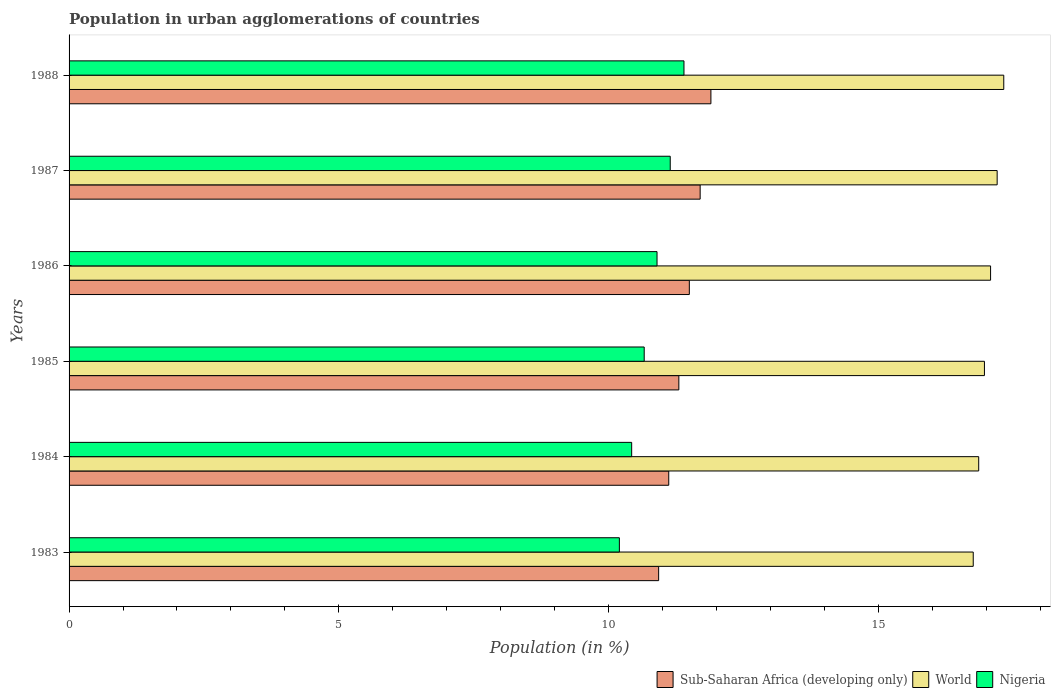How many different coloured bars are there?
Offer a very short reply. 3. How many groups of bars are there?
Ensure brevity in your answer.  6. Are the number of bars per tick equal to the number of legend labels?
Keep it short and to the point. Yes. How many bars are there on the 4th tick from the bottom?
Offer a terse response. 3. What is the label of the 6th group of bars from the top?
Keep it short and to the point. 1983. In how many cases, is the number of bars for a given year not equal to the number of legend labels?
Offer a very short reply. 0. What is the percentage of population in urban agglomerations in Nigeria in 1983?
Your answer should be compact. 10.2. Across all years, what is the maximum percentage of population in urban agglomerations in Sub-Saharan Africa (developing only)?
Your answer should be very brief. 11.9. Across all years, what is the minimum percentage of population in urban agglomerations in Sub-Saharan Africa (developing only)?
Offer a terse response. 10.93. In which year was the percentage of population in urban agglomerations in Nigeria minimum?
Your response must be concise. 1983. What is the total percentage of population in urban agglomerations in World in the graph?
Offer a very short reply. 102.2. What is the difference between the percentage of population in urban agglomerations in World in 1985 and that in 1987?
Your response must be concise. -0.24. What is the difference between the percentage of population in urban agglomerations in Sub-Saharan Africa (developing only) in 1988 and the percentage of population in urban agglomerations in World in 1984?
Offer a terse response. -4.96. What is the average percentage of population in urban agglomerations in World per year?
Provide a succinct answer. 17.03. In the year 1984, what is the difference between the percentage of population in urban agglomerations in World and percentage of population in urban agglomerations in Nigeria?
Provide a succinct answer. 6.43. What is the ratio of the percentage of population in urban agglomerations in Nigeria in 1985 to that in 1988?
Provide a succinct answer. 0.94. Is the difference between the percentage of population in urban agglomerations in World in 1985 and 1987 greater than the difference between the percentage of population in urban agglomerations in Nigeria in 1985 and 1987?
Your response must be concise. Yes. What is the difference between the highest and the second highest percentage of population in urban agglomerations in Sub-Saharan Africa (developing only)?
Give a very brief answer. 0.2. What is the difference between the highest and the lowest percentage of population in urban agglomerations in World?
Ensure brevity in your answer.  0.57. Is the sum of the percentage of population in urban agglomerations in Sub-Saharan Africa (developing only) in 1983 and 1984 greater than the maximum percentage of population in urban agglomerations in Nigeria across all years?
Provide a short and direct response. Yes. What does the 3rd bar from the top in 1988 represents?
Offer a very short reply. Sub-Saharan Africa (developing only). What does the 2nd bar from the bottom in 1987 represents?
Provide a short and direct response. World. Is it the case that in every year, the sum of the percentage of population in urban agglomerations in Sub-Saharan Africa (developing only) and percentage of population in urban agglomerations in Nigeria is greater than the percentage of population in urban agglomerations in World?
Ensure brevity in your answer.  Yes. Are all the bars in the graph horizontal?
Offer a terse response. Yes. How many years are there in the graph?
Provide a succinct answer. 6. Are the values on the major ticks of X-axis written in scientific E-notation?
Keep it short and to the point. No. Does the graph contain any zero values?
Give a very brief answer. No. Where does the legend appear in the graph?
Keep it short and to the point. Bottom right. How many legend labels are there?
Provide a succinct answer. 3. How are the legend labels stacked?
Offer a terse response. Horizontal. What is the title of the graph?
Give a very brief answer. Population in urban agglomerations of countries. What is the label or title of the Y-axis?
Your response must be concise. Years. What is the Population (in %) in Sub-Saharan Africa (developing only) in 1983?
Make the answer very short. 10.93. What is the Population (in %) in World in 1983?
Provide a short and direct response. 16.76. What is the Population (in %) in Nigeria in 1983?
Offer a terse response. 10.2. What is the Population (in %) in Sub-Saharan Africa (developing only) in 1984?
Keep it short and to the point. 11.12. What is the Population (in %) in World in 1984?
Offer a terse response. 16.86. What is the Population (in %) of Nigeria in 1984?
Your response must be concise. 10.43. What is the Population (in %) in Sub-Saharan Africa (developing only) in 1985?
Offer a very short reply. 11.3. What is the Population (in %) in World in 1985?
Keep it short and to the point. 16.97. What is the Population (in %) of Nigeria in 1985?
Your response must be concise. 10.66. What is the Population (in %) in Sub-Saharan Africa (developing only) in 1986?
Your answer should be very brief. 11.5. What is the Population (in %) of World in 1986?
Your answer should be compact. 17.08. What is the Population (in %) of Nigeria in 1986?
Offer a very short reply. 10.9. What is the Population (in %) of Sub-Saharan Africa (developing only) in 1987?
Make the answer very short. 11.7. What is the Population (in %) of World in 1987?
Give a very brief answer. 17.2. What is the Population (in %) of Nigeria in 1987?
Keep it short and to the point. 11.14. What is the Population (in %) in Sub-Saharan Africa (developing only) in 1988?
Keep it short and to the point. 11.9. What is the Population (in %) of World in 1988?
Provide a succinct answer. 17.33. What is the Population (in %) in Nigeria in 1988?
Provide a succinct answer. 11.4. Across all years, what is the maximum Population (in %) in Sub-Saharan Africa (developing only)?
Keep it short and to the point. 11.9. Across all years, what is the maximum Population (in %) of World?
Your response must be concise. 17.33. Across all years, what is the maximum Population (in %) in Nigeria?
Provide a short and direct response. 11.4. Across all years, what is the minimum Population (in %) in Sub-Saharan Africa (developing only)?
Keep it short and to the point. 10.93. Across all years, what is the minimum Population (in %) of World?
Your answer should be compact. 16.76. Across all years, what is the minimum Population (in %) in Nigeria?
Provide a succinct answer. 10.2. What is the total Population (in %) in Sub-Saharan Africa (developing only) in the graph?
Provide a succinct answer. 68.44. What is the total Population (in %) in World in the graph?
Offer a very short reply. 102.2. What is the total Population (in %) in Nigeria in the graph?
Provide a succinct answer. 64.73. What is the difference between the Population (in %) in Sub-Saharan Africa (developing only) in 1983 and that in 1984?
Your answer should be compact. -0.19. What is the difference between the Population (in %) in World in 1983 and that in 1984?
Make the answer very short. -0.1. What is the difference between the Population (in %) in Nigeria in 1983 and that in 1984?
Keep it short and to the point. -0.23. What is the difference between the Population (in %) of Sub-Saharan Africa (developing only) in 1983 and that in 1985?
Give a very brief answer. -0.37. What is the difference between the Population (in %) of World in 1983 and that in 1985?
Offer a very short reply. -0.21. What is the difference between the Population (in %) in Nigeria in 1983 and that in 1985?
Your answer should be very brief. -0.46. What is the difference between the Population (in %) of Sub-Saharan Africa (developing only) in 1983 and that in 1986?
Your answer should be compact. -0.57. What is the difference between the Population (in %) in World in 1983 and that in 1986?
Keep it short and to the point. -0.32. What is the difference between the Population (in %) in Nigeria in 1983 and that in 1986?
Make the answer very short. -0.7. What is the difference between the Population (in %) of Sub-Saharan Africa (developing only) in 1983 and that in 1987?
Your answer should be compact. -0.77. What is the difference between the Population (in %) of World in 1983 and that in 1987?
Provide a short and direct response. -0.44. What is the difference between the Population (in %) in Nigeria in 1983 and that in 1987?
Offer a terse response. -0.94. What is the difference between the Population (in %) in Sub-Saharan Africa (developing only) in 1983 and that in 1988?
Make the answer very short. -0.97. What is the difference between the Population (in %) in World in 1983 and that in 1988?
Your answer should be compact. -0.57. What is the difference between the Population (in %) of Nigeria in 1983 and that in 1988?
Ensure brevity in your answer.  -1.2. What is the difference between the Population (in %) of Sub-Saharan Africa (developing only) in 1984 and that in 1985?
Make the answer very short. -0.19. What is the difference between the Population (in %) in World in 1984 and that in 1985?
Give a very brief answer. -0.11. What is the difference between the Population (in %) of Nigeria in 1984 and that in 1985?
Keep it short and to the point. -0.23. What is the difference between the Population (in %) in Sub-Saharan Africa (developing only) in 1984 and that in 1986?
Provide a succinct answer. -0.38. What is the difference between the Population (in %) of World in 1984 and that in 1986?
Your response must be concise. -0.22. What is the difference between the Population (in %) of Nigeria in 1984 and that in 1986?
Your answer should be very brief. -0.47. What is the difference between the Population (in %) in Sub-Saharan Africa (developing only) in 1984 and that in 1987?
Provide a short and direct response. -0.58. What is the difference between the Population (in %) of World in 1984 and that in 1987?
Offer a very short reply. -0.34. What is the difference between the Population (in %) in Nigeria in 1984 and that in 1987?
Make the answer very short. -0.71. What is the difference between the Population (in %) of Sub-Saharan Africa (developing only) in 1984 and that in 1988?
Offer a terse response. -0.78. What is the difference between the Population (in %) of World in 1984 and that in 1988?
Provide a short and direct response. -0.46. What is the difference between the Population (in %) in Nigeria in 1984 and that in 1988?
Your response must be concise. -0.97. What is the difference between the Population (in %) in Sub-Saharan Africa (developing only) in 1985 and that in 1986?
Your answer should be very brief. -0.19. What is the difference between the Population (in %) of World in 1985 and that in 1986?
Your response must be concise. -0.11. What is the difference between the Population (in %) in Nigeria in 1985 and that in 1986?
Your answer should be compact. -0.24. What is the difference between the Population (in %) in Sub-Saharan Africa (developing only) in 1985 and that in 1987?
Your response must be concise. -0.4. What is the difference between the Population (in %) in World in 1985 and that in 1987?
Keep it short and to the point. -0.24. What is the difference between the Population (in %) in Nigeria in 1985 and that in 1987?
Provide a short and direct response. -0.48. What is the difference between the Population (in %) in Sub-Saharan Africa (developing only) in 1985 and that in 1988?
Make the answer very short. -0.59. What is the difference between the Population (in %) of World in 1985 and that in 1988?
Give a very brief answer. -0.36. What is the difference between the Population (in %) in Nigeria in 1985 and that in 1988?
Offer a very short reply. -0.74. What is the difference between the Population (in %) of Sub-Saharan Africa (developing only) in 1986 and that in 1987?
Provide a succinct answer. -0.2. What is the difference between the Population (in %) in World in 1986 and that in 1987?
Make the answer very short. -0.12. What is the difference between the Population (in %) of Nigeria in 1986 and that in 1987?
Your answer should be very brief. -0.24. What is the difference between the Population (in %) of Sub-Saharan Africa (developing only) in 1986 and that in 1988?
Your response must be concise. -0.4. What is the difference between the Population (in %) in World in 1986 and that in 1988?
Ensure brevity in your answer.  -0.24. What is the difference between the Population (in %) of Nigeria in 1986 and that in 1988?
Your answer should be very brief. -0.5. What is the difference between the Population (in %) in Sub-Saharan Africa (developing only) in 1987 and that in 1988?
Provide a short and direct response. -0.2. What is the difference between the Population (in %) of World in 1987 and that in 1988?
Offer a terse response. -0.12. What is the difference between the Population (in %) in Nigeria in 1987 and that in 1988?
Provide a succinct answer. -0.25. What is the difference between the Population (in %) in Sub-Saharan Africa (developing only) in 1983 and the Population (in %) in World in 1984?
Your response must be concise. -5.93. What is the difference between the Population (in %) of Sub-Saharan Africa (developing only) in 1983 and the Population (in %) of Nigeria in 1984?
Your answer should be compact. 0.5. What is the difference between the Population (in %) of World in 1983 and the Population (in %) of Nigeria in 1984?
Provide a short and direct response. 6.33. What is the difference between the Population (in %) of Sub-Saharan Africa (developing only) in 1983 and the Population (in %) of World in 1985?
Provide a short and direct response. -6.04. What is the difference between the Population (in %) of Sub-Saharan Africa (developing only) in 1983 and the Population (in %) of Nigeria in 1985?
Provide a short and direct response. 0.27. What is the difference between the Population (in %) in World in 1983 and the Population (in %) in Nigeria in 1985?
Keep it short and to the point. 6.1. What is the difference between the Population (in %) in Sub-Saharan Africa (developing only) in 1983 and the Population (in %) in World in 1986?
Ensure brevity in your answer.  -6.15. What is the difference between the Population (in %) in Sub-Saharan Africa (developing only) in 1983 and the Population (in %) in Nigeria in 1986?
Your answer should be very brief. 0.03. What is the difference between the Population (in %) of World in 1983 and the Population (in %) of Nigeria in 1986?
Provide a short and direct response. 5.86. What is the difference between the Population (in %) in Sub-Saharan Africa (developing only) in 1983 and the Population (in %) in World in 1987?
Provide a short and direct response. -6.28. What is the difference between the Population (in %) of Sub-Saharan Africa (developing only) in 1983 and the Population (in %) of Nigeria in 1987?
Your answer should be very brief. -0.21. What is the difference between the Population (in %) in World in 1983 and the Population (in %) in Nigeria in 1987?
Your response must be concise. 5.62. What is the difference between the Population (in %) of Sub-Saharan Africa (developing only) in 1983 and the Population (in %) of World in 1988?
Provide a succinct answer. -6.4. What is the difference between the Population (in %) in Sub-Saharan Africa (developing only) in 1983 and the Population (in %) in Nigeria in 1988?
Your answer should be compact. -0.47. What is the difference between the Population (in %) in World in 1983 and the Population (in %) in Nigeria in 1988?
Keep it short and to the point. 5.36. What is the difference between the Population (in %) in Sub-Saharan Africa (developing only) in 1984 and the Population (in %) in World in 1985?
Your answer should be very brief. -5.85. What is the difference between the Population (in %) in Sub-Saharan Africa (developing only) in 1984 and the Population (in %) in Nigeria in 1985?
Provide a succinct answer. 0.45. What is the difference between the Population (in %) of World in 1984 and the Population (in %) of Nigeria in 1985?
Your answer should be compact. 6.2. What is the difference between the Population (in %) of Sub-Saharan Africa (developing only) in 1984 and the Population (in %) of World in 1986?
Give a very brief answer. -5.97. What is the difference between the Population (in %) in Sub-Saharan Africa (developing only) in 1984 and the Population (in %) in Nigeria in 1986?
Offer a very short reply. 0.22. What is the difference between the Population (in %) in World in 1984 and the Population (in %) in Nigeria in 1986?
Provide a short and direct response. 5.96. What is the difference between the Population (in %) of Sub-Saharan Africa (developing only) in 1984 and the Population (in %) of World in 1987?
Provide a short and direct response. -6.09. What is the difference between the Population (in %) of Sub-Saharan Africa (developing only) in 1984 and the Population (in %) of Nigeria in 1987?
Provide a succinct answer. -0.03. What is the difference between the Population (in %) of World in 1984 and the Population (in %) of Nigeria in 1987?
Give a very brief answer. 5.72. What is the difference between the Population (in %) in Sub-Saharan Africa (developing only) in 1984 and the Population (in %) in World in 1988?
Keep it short and to the point. -6.21. What is the difference between the Population (in %) of Sub-Saharan Africa (developing only) in 1984 and the Population (in %) of Nigeria in 1988?
Give a very brief answer. -0.28. What is the difference between the Population (in %) of World in 1984 and the Population (in %) of Nigeria in 1988?
Offer a very short reply. 5.46. What is the difference between the Population (in %) of Sub-Saharan Africa (developing only) in 1985 and the Population (in %) of World in 1986?
Ensure brevity in your answer.  -5.78. What is the difference between the Population (in %) in Sub-Saharan Africa (developing only) in 1985 and the Population (in %) in Nigeria in 1986?
Make the answer very short. 0.4. What is the difference between the Population (in %) in World in 1985 and the Population (in %) in Nigeria in 1986?
Your answer should be very brief. 6.07. What is the difference between the Population (in %) in Sub-Saharan Africa (developing only) in 1985 and the Population (in %) in World in 1987?
Make the answer very short. -5.9. What is the difference between the Population (in %) of Sub-Saharan Africa (developing only) in 1985 and the Population (in %) of Nigeria in 1987?
Offer a very short reply. 0.16. What is the difference between the Population (in %) of World in 1985 and the Population (in %) of Nigeria in 1987?
Keep it short and to the point. 5.82. What is the difference between the Population (in %) in Sub-Saharan Africa (developing only) in 1985 and the Population (in %) in World in 1988?
Your response must be concise. -6.02. What is the difference between the Population (in %) of Sub-Saharan Africa (developing only) in 1985 and the Population (in %) of Nigeria in 1988?
Your response must be concise. -0.09. What is the difference between the Population (in %) of World in 1985 and the Population (in %) of Nigeria in 1988?
Your answer should be very brief. 5.57. What is the difference between the Population (in %) in Sub-Saharan Africa (developing only) in 1986 and the Population (in %) in World in 1987?
Ensure brevity in your answer.  -5.71. What is the difference between the Population (in %) in Sub-Saharan Africa (developing only) in 1986 and the Population (in %) in Nigeria in 1987?
Ensure brevity in your answer.  0.35. What is the difference between the Population (in %) in World in 1986 and the Population (in %) in Nigeria in 1987?
Offer a very short reply. 5.94. What is the difference between the Population (in %) in Sub-Saharan Africa (developing only) in 1986 and the Population (in %) in World in 1988?
Your answer should be compact. -5.83. What is the difference between the Population (in %) in Sub-Saharan Africa (developing only) in 1986 and the Population (in %) in Nigeria in 1988?
Your answer should be very brief. 0.1. What is the difference between the Population (in %) of World in 1986 and the Population (in %) of Nigeria in 1988?
Make the answer very short. 5.68. What is the difference between the Population (in %) of Sub-Saharan Africa (developing only) in 1987 and the Population (in %) of World in 1988?
Ensure brevity in your answer.  -5.63. What is the difference between the Population (in %) in Sub-Saharan Africa (developing only) in 1987 and the Population (in %) in Nigeria in 1988?
Provide a short and direct response. 0.3. What is the difference between the Population (in %) in World in 1987 and the Population (in %) in Nigeria in 1988?
Provide a short and direct response. 5.81. What is the average Population (in %) of Sub-Saharan Africa (developing only) per year?
Your answer should be very brief. 11.41. What is the average Population (in %) in World per year?
Ensure brevity in your answer.  17.03. What is the average Population (in %) of Nigeria per year?
Offer a terse response. 10.79. In the year 1983, what is the difference between the Population (in %) in Sub-Saharan Africa (developing only) and Population (in %) in World?
Make the answer very short. -5.83. In the year 1983, what is the difference between the Population (in %) in Sub-Saharan Africa (developing only) and Population (in %) in Nigeria?
Ensure brevity in your answer.  0.73. In the year 1983, what is the difference between the Population (in %) in World and Population (in %) in Nigeria?
Provide a succinct answer. 6.56. In the year 1984, what is the difference between the Population (in %) of Sub-Saharan Africa (developing only) and Population (in %) of World?
Provide a succinct answer. -5.75. In the year 1984, what is the difference between the Population (in %) of Sub-Saharan Africa (developing only) and Population (in %) of Nigeria?
Keep it short and to the point. 0.69. In the year 1984, what is the difference between the Population (in %) of World and Population (in %) of Nigeria?
Your answer should be compact. 6.43. In the year 1985, what is the difference between the Population (in %) in Sub-Saharan Africa (developing only) and Population (in %) in World?
Your answer should be compact. -5.66. In the year 1985, what is the difference between the Population (in %) in Sub-Saharan Africa (developing only) and Population (in %) in Nigeria?
Offer a very short reply. 0.64. In the year 1985, what is the difference between the Population (in %) of World and Population (in %) of Nigeria?
Make the answer very short. 6.31. In the year 1986, what is the difference between the Population (in %) of Sub-Saharan Africa (developing only) and Population (in %) of World?
Provide a short and direct response. -5.58. In the year 1986, what is the difference between the Population (in %) of Sub-Saharan Africa (developing only) and Population (in %) of Nigeria?
Make the answer very short. 0.6. In the year 1986, what is the difference between the Population (in %) of World and Population (in %) of Nigeria?
Ensure brevity in your answer.  6.18. In the year 1987, what is the difference between the Population (in %) in Sub-Saharan Africa (developing only) and Population (in %) in World?
Give a very brief answer. -5.51. In the year 1987, what is the difference between the Population (in %) in Sub-Saharan Africa (developing only) and Population (in %) in Nigeria?
Give a very brief answer. 0.55. In the year 1987, what is the difference between the Population (in %) of World and Population (in %) of Nigeria?
Provide a short and direct response. 6.06. In the year 1988, what is the difference between the Population (in %) of Sub-Saharan Africa (developing only) and Population (in %) of World?
Give a very brief answer. -5.43. In the year 1988, what is the difference between the Population (in %) of Sub-Saharan Africa (developing only) and Population (in %) of Nigeria?
Your answer should be very brief. 0.5. In the year 1988, what is the difference between the Population (in %) of World and Population (in %) of Nigeria?
Your response must be concise. 5.93. What is the ratio of the Population (in %) of Sub-Saharan Africa (developing only) in 1983 to that in 1984?
Your answer should be compact. 0.98. What is the ratio of the Population (in %) of World in 1983 to that in 1984?
Provide a short and direct response. 0.99. What is the ratio of the Population (in %) in Nigeria in 1983 to that in 1984?
Your answer should be compact. 0.98. What is the ratio of the Population (in %) in Sub-Saharan Africa (developing only) in 1983 to that in 1985?
Give a very brief answer. 0.97. What is the ratio of the Population (in %) in Nigeria in 1983 to that in 1985?
Provide a short and direct response. 0.96. What is the ratio of the Population (in %) in Sub-Saharan Africa (developing only) in 1983 to that in 1986?
Offer a terse response. 0.95. What is the ratio of the Population (in %) in World in 1983 to that in 1986?
Your response must be concise. 0.98. What is the ratio of the Population (in %) of Nigeria in 1983 to that in 1986?
Offer a terse response. 0.94. What is the ratio of the Population (in %) in Sub-Saharan Africa (developing only) in 1983 to that in 1987?
Your answer should be compact. 0.93. What is the ratio of the Population (in %) in World in 1983 to that in 1987?
Offer a very short reply. 0.97. What is the ratio of the Population (in %) in Nigeria in 1983 to that in 1987?
Your answer should be very brief. 0.92. What is the ratio of the Population (in %) in Sub-Saharan Africa (developing only) in 1983 to that in 1988?
Ensure brevity in your answer.  0.92. What is the ratio of the Population (in %) in World in 1983 to that in 1988?
Provide a succinct answer. 0.97. What is the ratio of the Population (in %) in Nigeria in 1983 to that in 1988?
Offer a very short reply. 0.89. What is the ratio of the Population (in %) in Sub-Saharan Africa (developing only) in 1984 to that in 1985?
Offer a terse response. 0.98. What is the ratio of the Population (in %) of World in 1984 to that in 1985?
Ensure brevity in your answer.  0.99. What is the ratio of the Population (in %) of Nigeria in 1984 to that in 1985?
Your response must be concise. 0.98. What is the ratio of the Population (in %) in Sub-Saharan Africa (developing only) in 1984 to that in 1986?
Offer a terse response. 0.97. What is the ratio of the Population (in %) of World in 1984 to that in 1986?
Ensure brevity in your answer.  0.99. What is the ratio of the Population (in %) in Nigeria in 1984 to that in 1986?
Your answer should be very brief. 0.96. What is the ratio of the Population (in %) of Sub-Saharan Africa (developing only) in 1984 to that in 1987?
Ensure brevity in your answer.  0.95. What is the ratio of the Population (in %) of World in 1984 to that in 1987?
Keep it short and to the point. 0.98. What is the ratio of the Population (in %) in Nigeria in 1984 to that in 1987?
Ensure brevity in your answer.  0.94. What is the ratio of the Population (in %) of Sub-Saharan Africa (developing only) in 1984 to that in 1988?
Provide a short and direct response. 0.93. What is the ratio of the Population (in %) in World in 1984 to that in 1988?
Your answer should be very brief. 0.97. What is the ratio of the Population (in %) of Nigeria in 1984 to that in 1988?
Give a very brief answer. 0.92. What is the ratio of the Population (in %) of Sub-Saharan Africa (developing only) in 1985 to that in 1986?
Your answer should be compact. 0.98. What is the ratio of the Population (in %) of Nigeria in 1985 to that in 1986?
Keep it short and to the point. 0.98. What is the ratio of the Population (in %) in Sub-Saharan Africa (developing only) in 1985 to that in 1987?
Give a very brief answer. 0.97. What is the ratio of the Population (in %) of World in 1985 to that in 1987?
Your answer should be compact. 0.99. What is the ratio of the Population (in %) of Nigeria in 1985 to that in 1987?
Provide a succinct answer. 0.96. What is the ratio of the Population (in %) of Sub-Saharan Africa (developing only) in 1985 to that in 1988?
Offer a terse response. 0.95. What is the ratio of the Population (in %) of World in 1985 to that in 1988?
Offer a very short reply. 0.98. What is the ratio of the Population (in %) of Nigeria in 1985 to that in 1988?
Provide a succinct answer. 0.94. What is the ratio of the Population (in %) in Sub-Saharan Africa (developing only) in 1986 to that in 1987?
Your answer should be compact. 0.98. What is the ratio of the Population (in %) in World in 1986 to that in 1987?
Offer a very short reply. 0.99. What is the ratio of the Population (in %) in Nigeria in 1986 to that in 1987?
Ensure brevity in your answer.  0.98. What is the ratio of the Population (in %) in Sub-Saharan Africa (developing only) in 1986 to that in 1988?
Provide a succinct answer. 0.97. What is the ratio of the Population (in %) in World in 1986 to that in 1988?
Make the answer very short. 0.99. What is the ratio of the Population (in %) in Nigeria in 1986 to that in 1988?
Give a very brief answer. 0.96. What is the ratio of the Population (in %) of Sub-Saharan Africa (developing only) in 1987 to that in 1988?
Offer a very short reply. 0.98. What is the ratio of the Population (in %) in World in 1987 to that in 1988?
Ensure brevity in your answer.  0.99. What is the ratio of the Population (in %) in Nigeria in 1987 to that in 1988?
Your answer should be very brief. 0.98. What is the difference between the highest and the second highest Population (in %) of Sub-Saharan Africa (developing only)?
Offer a very short reply. 0.2. What is the difference between the highest and the second highest Population (in %) in World?
Offer a very short reply. 0.12. What is the difference between the highest and the second highest Population (in %) of Nigeria?
Give a very brief answer. 0.25. What is the difference between the highest and the lowest Population (in %) in Sub-Saharan Africa (developing only)?
Your answer should be compact. 0.97. What is the difference between the highest and the lowest Population (in %) in World?
Your answer should be very brief. 0.57. What is the difference between the highest and the lowest Population (in %) in Nigeria?
Give a very brief answer. 1.2. 